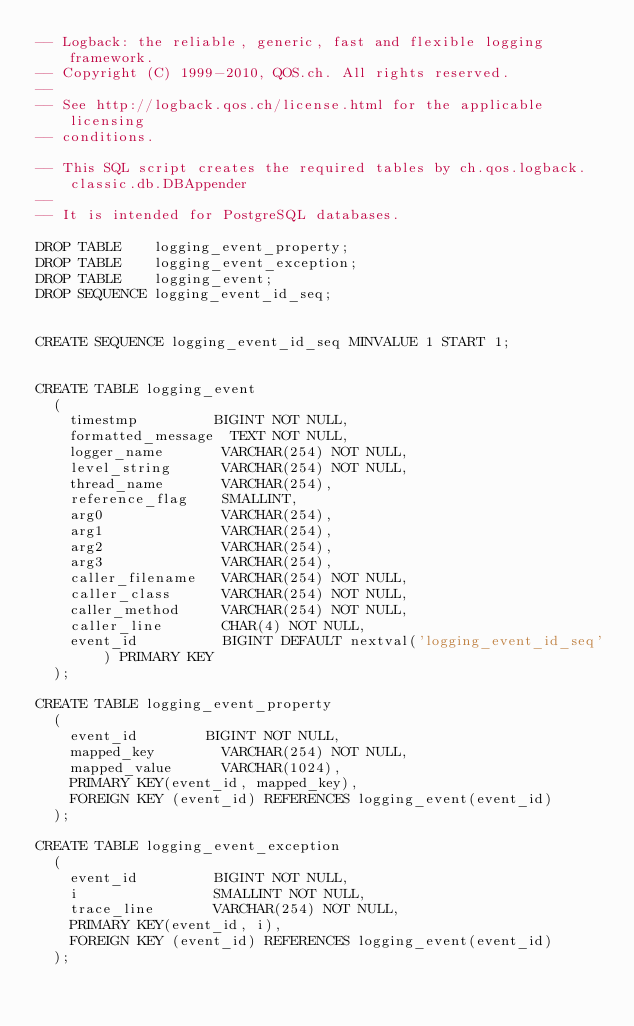<code> <loc_0><loc_0><loc_500><loc_500><_SQL_>-- Logback: the reliable, generic, fast and flexible logging framework.
-- Copyright (C) 1999-2010, QOS.ch. All rights reserved.
--
-- See http://logback.qos.ch/license.html for the applicable licensing 
-- conditions.

-- This SQL script creates the required tables by ch.qos.logback.classic.db.DBAppender
--
-- It is intended for PostgreSQL databases.

DROP TABLE    logging_event_property;
DROP TABLE    logging_event_exception;
DROP TABLE    logging_event;
DROP SEQUENCE logging_event_id_seq;


CREATE SEQUENCE logging_event_id_seq MINVALUE 1 START 1;


CREATE TABLE logging_event 
  (
    timestmp         BIGINT NOT NULL,
    formatted_message  TEXT NOT NULL,
    logger_name       VARCHAR(254) NOT NULL,
    level_string      VARCHAR(254) NOT NULL,
    thread_name       VARCHAR(254),
    reference_flag    SMALLINT,
    arg0              VARCHAR(254),
    arg1              VARCHAR(254),
    arg2              VARCHAR(254),
    arg3              VARCHAR(254),
    caller_filename   VARCHAR(254) NOT NULL,
    caller_class      VARCHAR(254) NOT NULL,
    caller_method     VARCHAR(254) NOT NULL,
    caller_line       CHAR(4) NOT NULL,
    event_id          BIGINT DEFAULT nextval('logging_event_id_seq') PRIMARY KEY
  );

CREATE TABLE logging_event_property
  (
    event_id	      BIGINT NOT NULL,
    mapped_key        VARCHAR(254) NOT NULL,
    mapped_value      VARCHAR(1024),
    PRIMARY KEY(event_id, mapped_key),
    FOREIGN KEY (event_id) REFERENCES logging_event(event_id)
  );

CREATE TABLE logging_event_exception
  (
    event_id         BIGINT NOT NULL,
    i                SMALLINT NOT NULL,
    trace_line       VARCHAR(254) NOT NULL,
    PRIMARY KEY(event_id, i),
    FOREIGN KEY (event_id) REFERENCES logging_event(event_id)
  );
</code> 